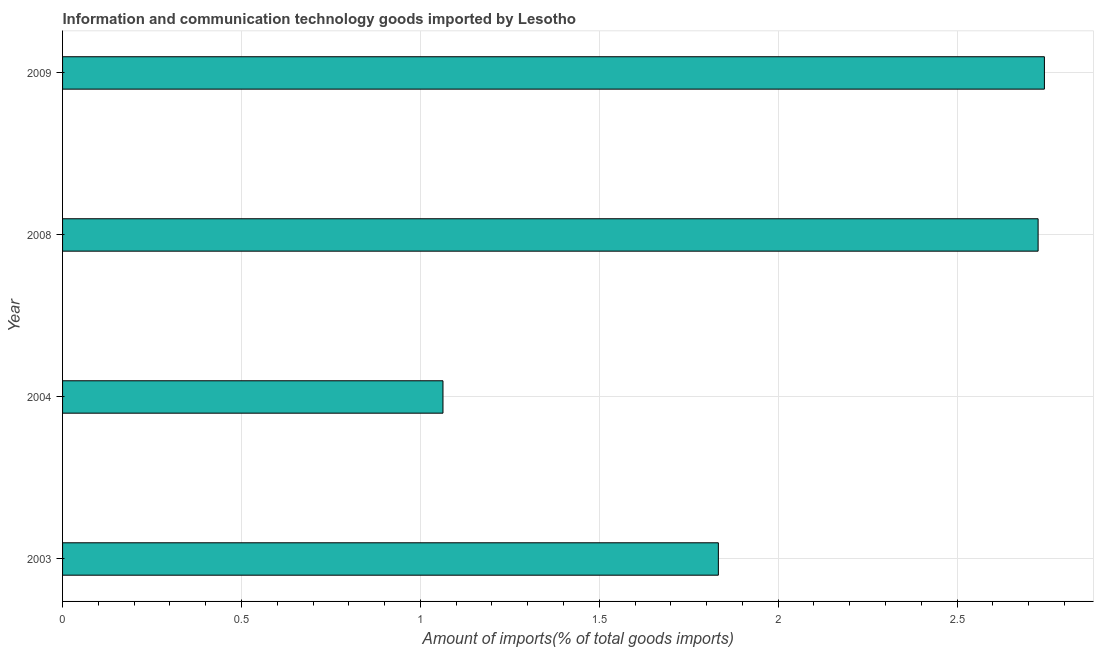What is the title of the graph?
Ensure brevity in your answer.  Information and communication technology goods imported by Lesotho. What is the label or title of the X-axis?
Offer a very short reply. Amount of imports(% of total goods imports). What is the amount of ict goods imports in 2003?
Offer a very short reply. 1.83. Across all years, what is the maximum amount of ict goods imports?
Make the answer very short. 2.74. Across all years, what is the minimum amount of ict goods imports?
Make the answer very short. 1.06. In which year was the amount of ict goods imports minimum?
Your answer should be very brief. 2004. What is the sum of the amount of ict goods imports?
Offer a very short reply. 8.37. What is the difference between the amount of ict goods imports in 2004 and 2009?
Keep it short and to the point. -1.68. What is the average amount of ict goods imports per year?
Your answer should be compact. 2.09. What is the median amount of ict goods imports?
Your answer should be compact. 2.28. In how many years, is the amount of ict goods imports greater than 1.2 %?
Make the answer very short. 3. Do a majority of the years between 2003 and 2008 (inclusive) have amount of ict goods imports greater than 0.4 %?
Your response must be concise. Yes. What is the ratio of the amount of ict goods imports in 2004 to that in 2009?
Keep it short and to the point. 0.39. Is the difference between the amount of ict goods imports in 2003 and 2008 greater than the difference between any two years?
Provide a succinct answer. No. What is the difference between the highest and the second highest amount of ict goods imports?
Your response must be concise. 0.02. What is the difference between the highest and the lowest amount of ict goods imports?
Ensure brevity in your answer.  1.68. In how many years, is the amount of ict goods imports greater than the average amount of ict goods imports taken over all years?
Provide a short and direct response. 2. How many years are there in the graph?
Keep it short and to the point. 4. Are the values on the major ticks of X-axis written in scientific E-notation?
Your answer should be very brief. No. What is the Amount of imports(% of total goods imports) of 2003?
Offer a very short reply. 1.83. What is the Amount of imports(% of total goods imports) in 2004?
Offer a terse response. 1.06. What is the Amount of imports(% of total goods imports) of 2008?
Offer a very short reply. 2.73. What is the Amount of imports(% of total goods imports) of 2009?
Offer a very short reply. 2.74. What is the difference between the Amount of imports(% of total goods imports) in 2003 and 2004?
Offer a very short reply. 0.77. What is the difference between the Amount of imports(% of total goods imports) in 2003 and 2008?
Offer a very short reply. -0.89. What is the difference between the Amount of imports(% of total goods imports) in 2003 and 2009?
Keep it short and to the point. -0.91. What is the difference between the Amount of imports(% of total goods imports) in 2004 and 2008?
Your answer should be compact. -1.66. What is the difference between the Amount of imports(% of total goods imports) in 2004 and 2009?
Provide a succinct answer. -1.68. What is the difference between the Amount of imports(% of total goods imports) in 2008 and 2009?
Keep it short and to the point. -0.02. What is the ratio of the Amount of imports(% of total goods imports) in 2003 to that in 2004?
Provide a short and direct response. 1.72. What is the ratio of the Amount of imports(% of total goods imports) in 2003 to that in 2008?
Your response must be concise. 0.67. What is the ratio of the Amount of imports(% of total goods imports) in 2003 to that in 2009?
Keep it short and to the point. 0.67. What is the ratio of the Amount of imports(% of total goods imports) in 2004 to that in 2008?
Ensure brevity in your answer.  0.39. What is the ratio of the Amount of imports(% of total goods imports) in 2004 to that in 2009?
Your answer should be very brief. 0.39. What is the ratio of the Amount of imports(% of total goods imports) in 2008 to that in 2009?
Provide a short and direct response. 0.99. 